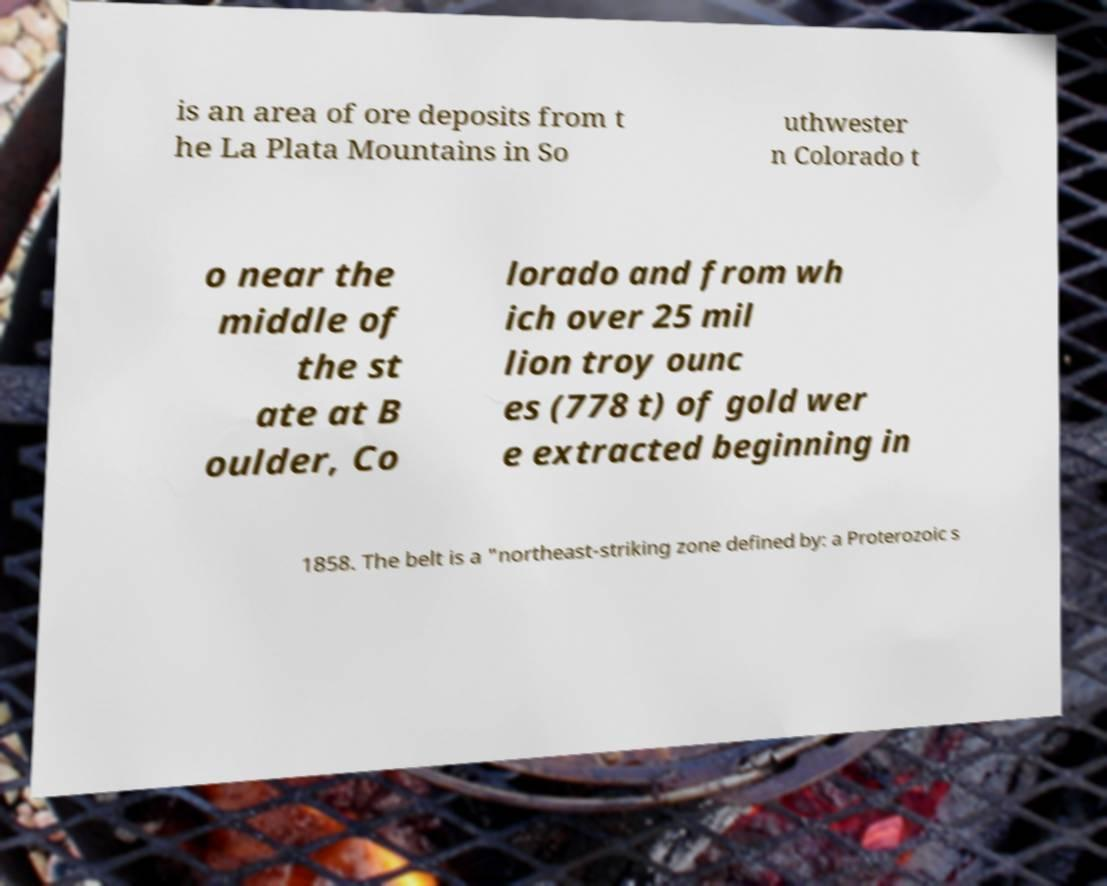There's text embedded in this image that I need extracted. Can you transcribe it verbatim? is an area of ore deposits from t he La Plata Mountains in So uthwester n Colorado t o near the middle of the st ate at B oulder, Co lorado and from wh ich over 25 mil lion troy ounc es (778 t) of gold wer e extracted beginning in 1858. The belt is a "northeast-striking zone defined by: a Proterozoic s 